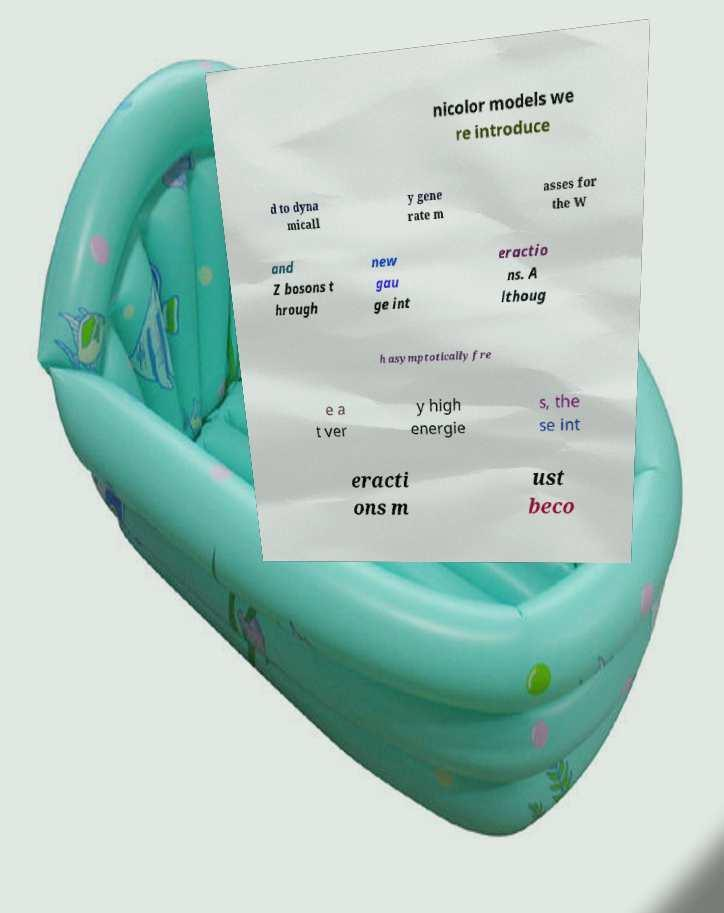Please identify and transcribe the text found in this image. nicolor models we re introduce d to dyna micall y gene rate m asses for the W and Z bosons t hrough new gau ge int eractio ns. A lthoug h asymptotically fre e a t ver y high energie s, the se int eracti ons m ust beco 